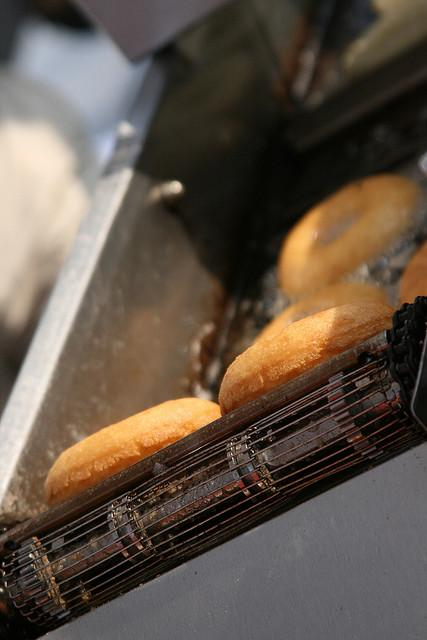What step of donut creation is this scene at?

Choices:
A) frying
B) cutting
C) adding sprinkles
D) adding glaze frying 